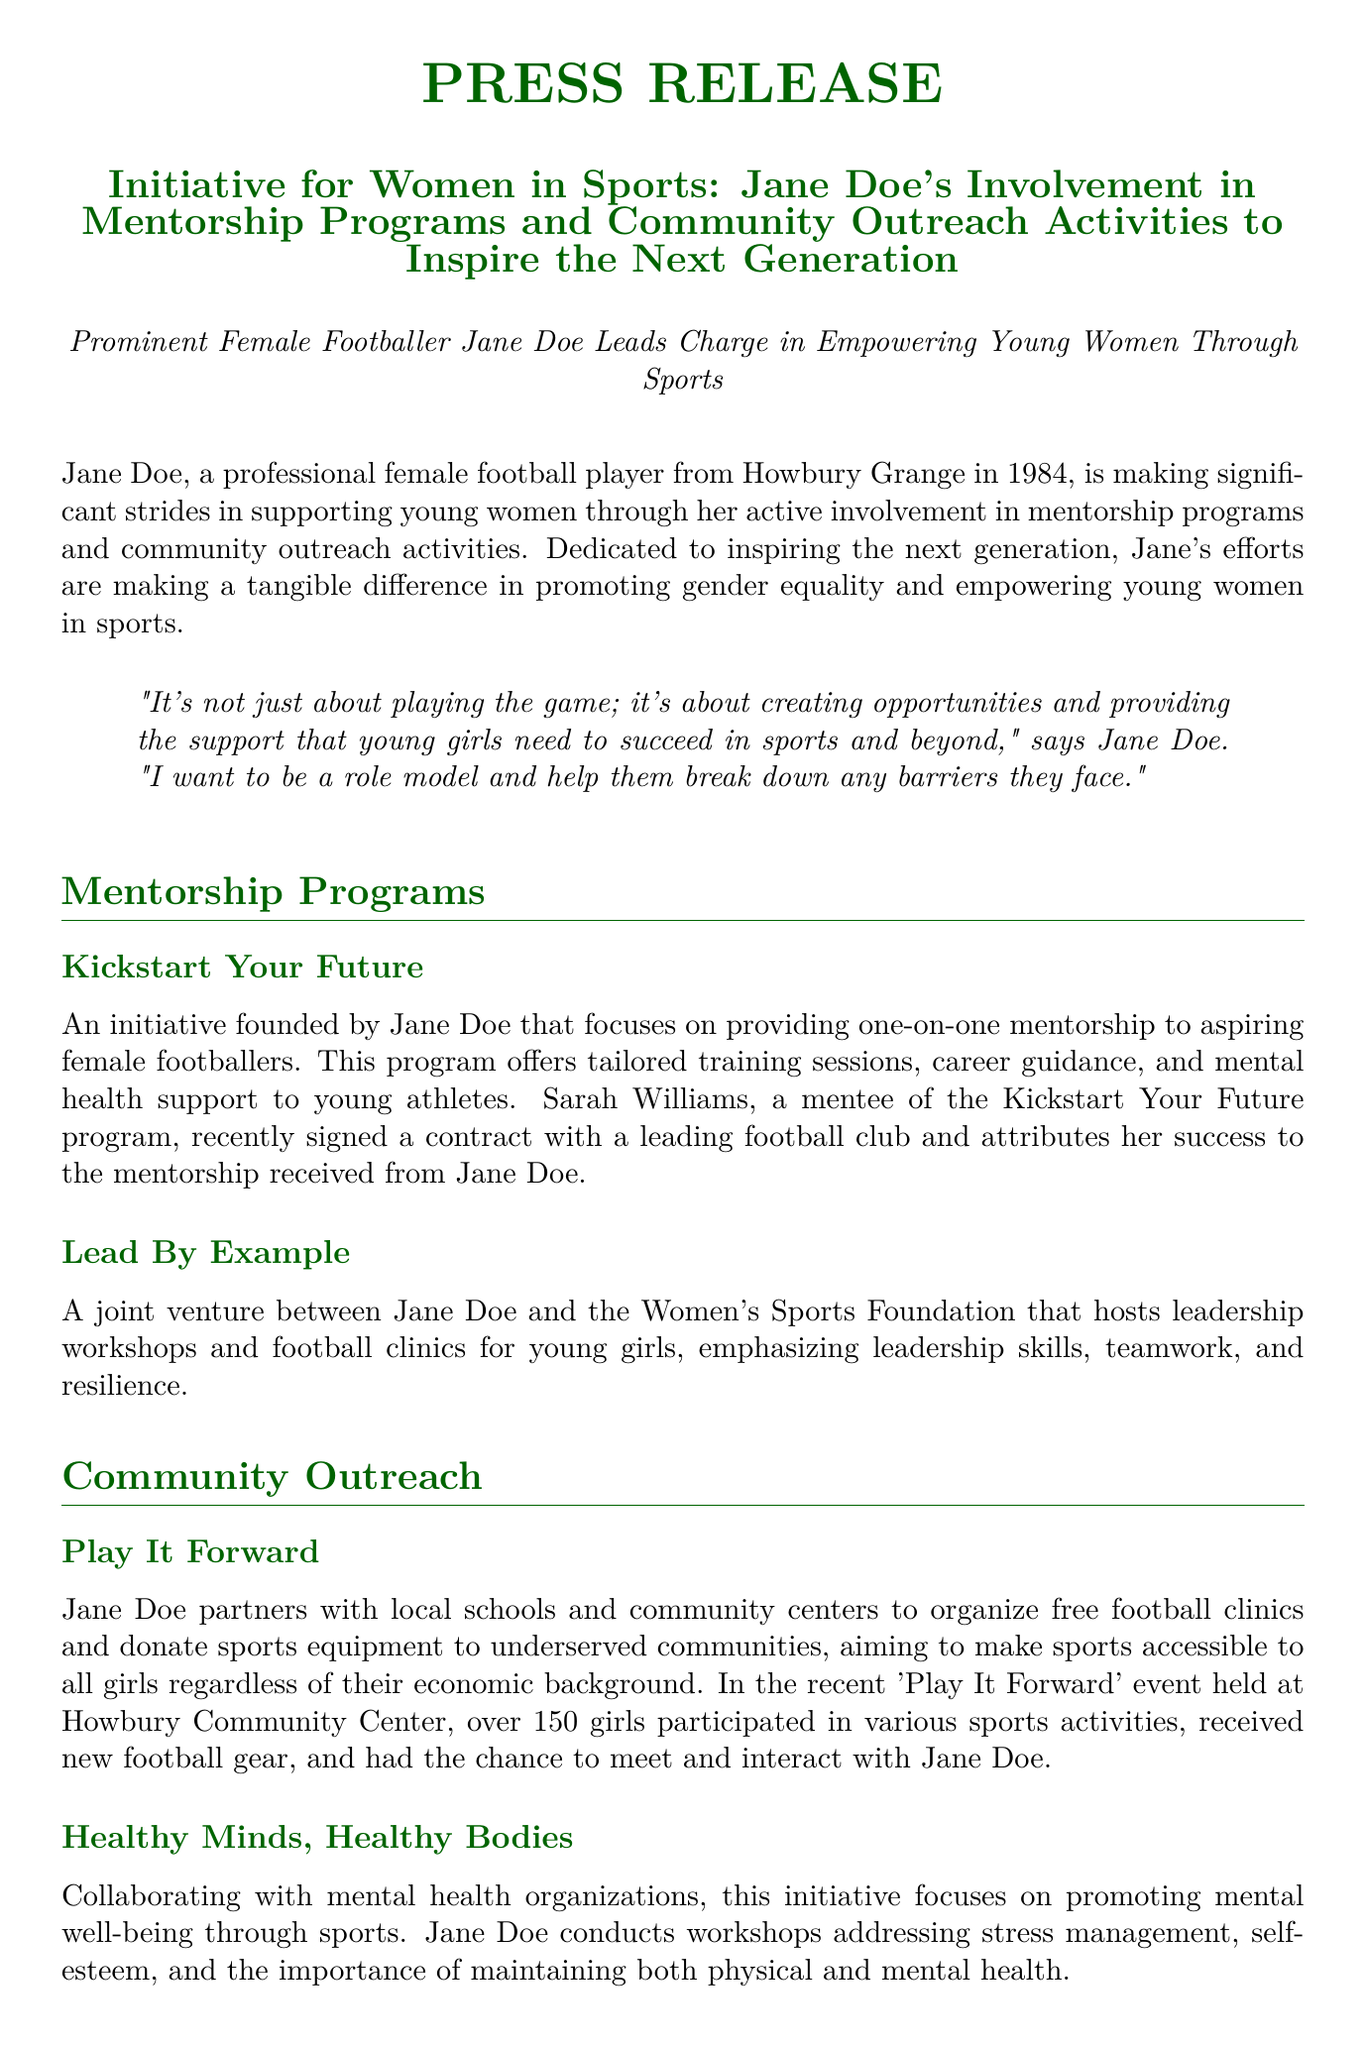What is the name of the program founded by Jane Doe? The program is specifically mentioned as "Kickstart Your Future."
Answer: Kickstart Your Future What year did Jane Doe become a professional football player? The document states that Jane Doe is from Howbury Grange in 1984.
Answer: 1984 How many girls participated in the 'Play It Forward' event? The document mentions that over 150 girls participated in the event.
Answer: 150 What organization did Jane Doe collaborate with for leadership workshops? The Women's Sports Foundation is specifically mentioned as the organization for workshops.
Answer: Women's Sports Foundation Who is mentioned as a mentee of the Kickstart Your Future program? Sarah Williams is identified as a mentee who signed a contract with a leading football club.
Answer: Sarah Williams What is the focus of the "Healthy Minds, Healthy Bodies" initiative? The initiative focuses on promoting mental well-being through sports.
Answer: Mental well-being What is Jane Doe's role in community outreach according to the document? Jane Doe partners with schools and community centers for free football clinics.
Answer: Partners with schools What is Jane Doe's email address provided in the document? The document specifies her email address as janedoe@womeninsports.org.
Answer: janedoe@womeninsports.org What does Jane's quote emphasize about her involvement in sports? The quote discusses creating opportunities and the support needed by young girls.
Answer: Creating opportunities 